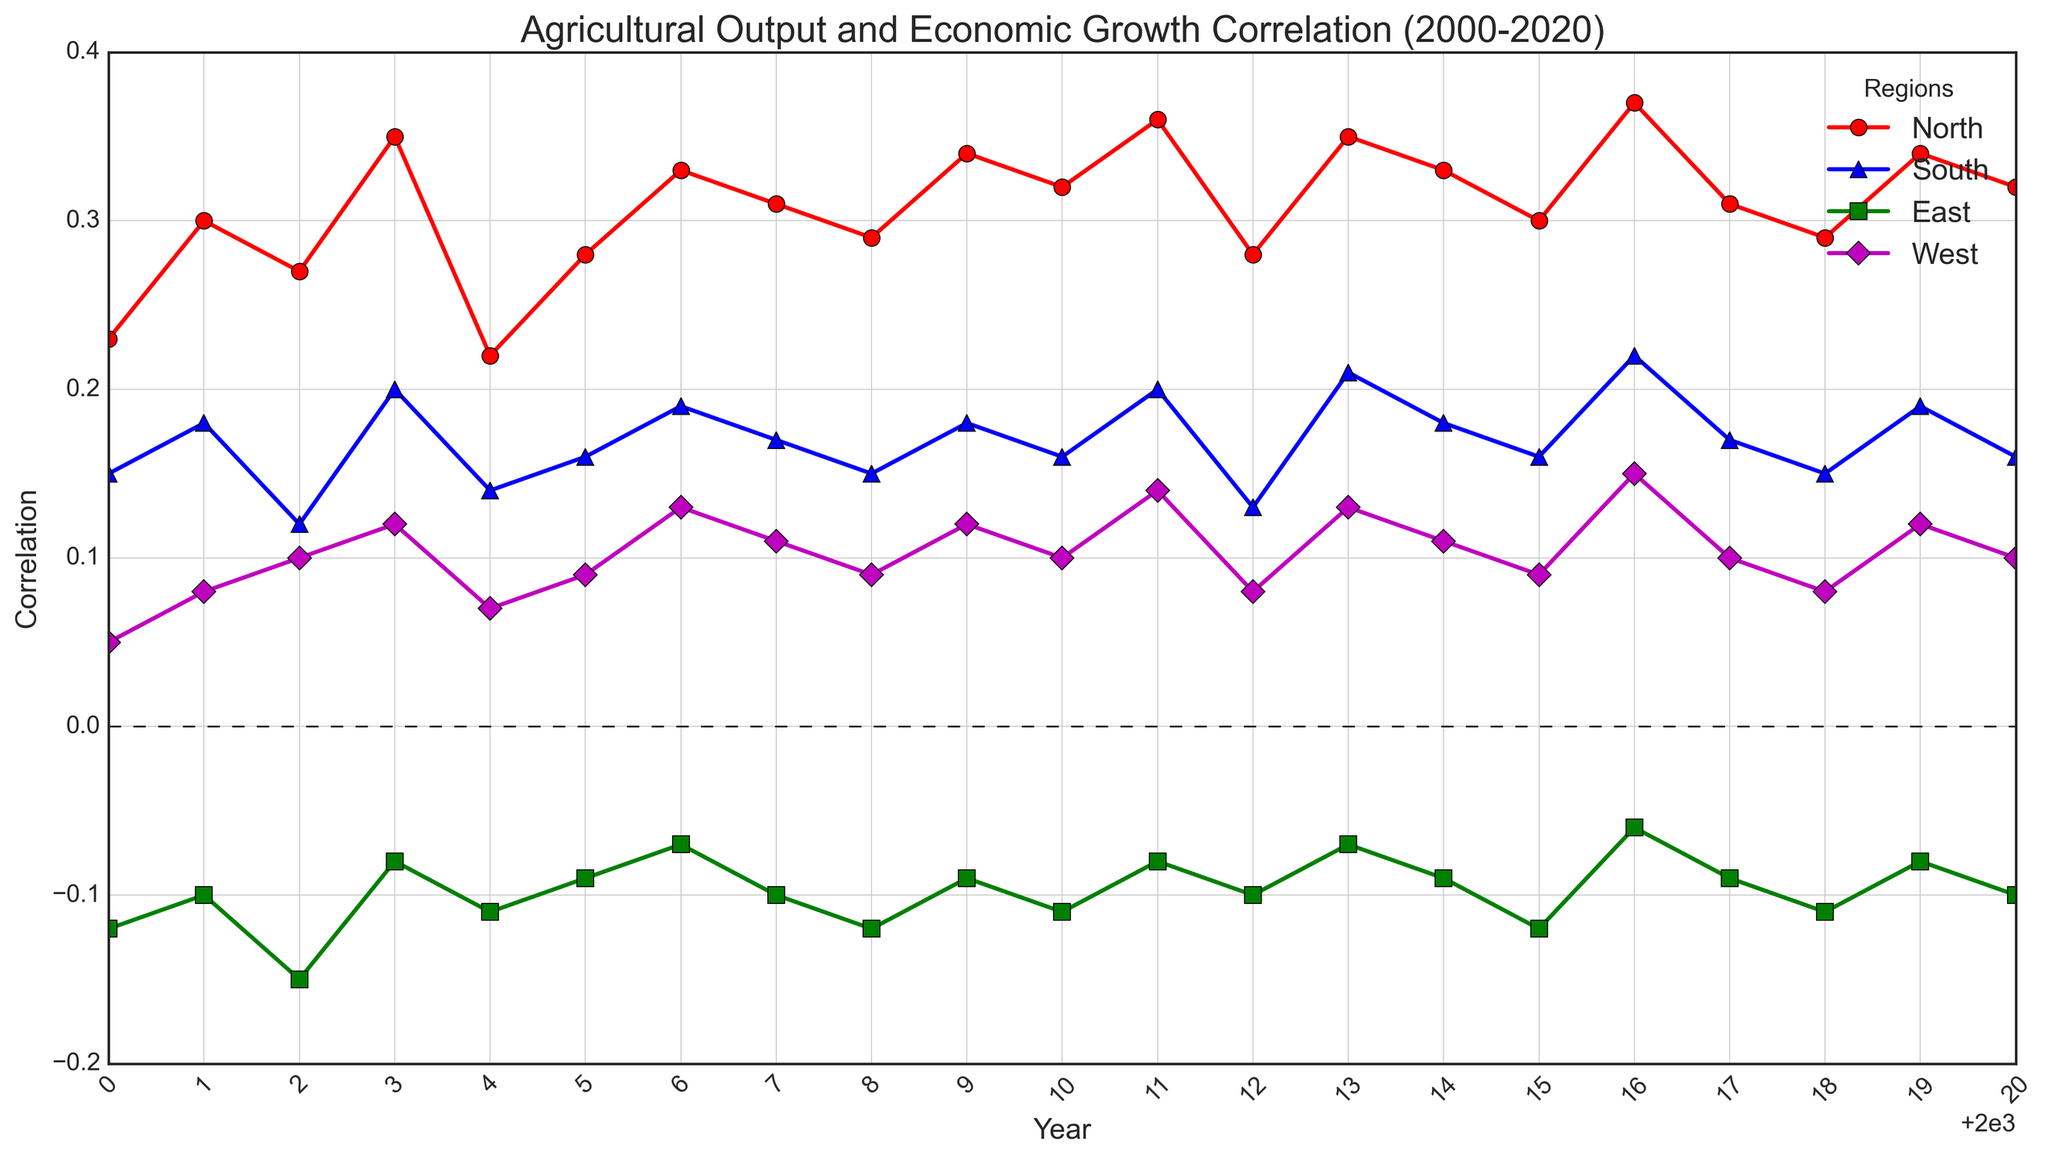What is the trend in the correlation for the North region from 2000 to 2020? Over the years 2000 to 2020, the correlation values for the North region generally show an increasing trend with some fluctuations. Specifically, it starts from 0.23 in 2000, reaches a high of 0.37 in 2016, and then varies slightly, ending at 0.32 in 2020.
Answer: Generally increasing Which region showed the maximum positive correlation in any year from 2000 to 2020? By examining the peak values of the correlations for each region across the years, the North region showed the maximum positive correlation value of 0.37 in the year 2016.
Answer: North, 2016 Which region had a negative correlation most consistently between 2000 and 2020? Observing the trend lines for each region, the East region consistently shows negative values across all years, indicating it had a consistently negative correlation between agricultural output and economic growth.
Answer: East In which year did the West region first exceed a correlation of 0.10? Looking at the data points for the West region, the year in which the correlation first exceeded 0.10 was 2003.
Answer: 2003 How did the correlation in the South region change from 2015 to 2016? In 2015, the correlation for the South region was 0.16. It increased to 0.22 in 2016, indicating a positive change.
Answer: Increased by 0.06 Compare the average correlation from 2000 to 2020 between the North and South regions. To calculate, sum the correlation values for each year for both regions and divide by the number of years (21). For North: (0.23 + 0.30 + ... + 0.32)/21. For South: (0.15 + 0.18 + ... + 0.16)/21. The North region has a higher average correlation than the South region.
Answer: North has a higher average correlation During which years did the East region's correlation improve from a negative value closer to zero? Observing the East region's trend, the years where it improved (became less negative) closer to zero include 2001 (-0.10) to 2003 (-0.08), 2005 (-0.09) to 2006 (-0.07), 2013 (-0.07) to 2014 (-0.09), and 2018 (-0.11) to 2019 (-0.08).
Answer: 2001-2003, 2005-2006, 2013-2014, 2018-2019 Between 2008 and 2009, which region showed the largest increase in correlation? By comparing the values for each region between 2008 and 2009, the North region showed an increase from 0.29 to 0.34, an increase of 0.05. South increased from 0.15 to 0.18 (0.03), East from -0.12 to -0.09 (0.03), and West from 0.09 to 0.12 (0.03). Therefore, the North region had the largest increase.
Answer: North What is the minimum correlation value observed in the East region and in which year did it occur? The minimum correlation value for the East region is -0.15, which occurred in the year 2002.
Answer: -0.15, 2002 